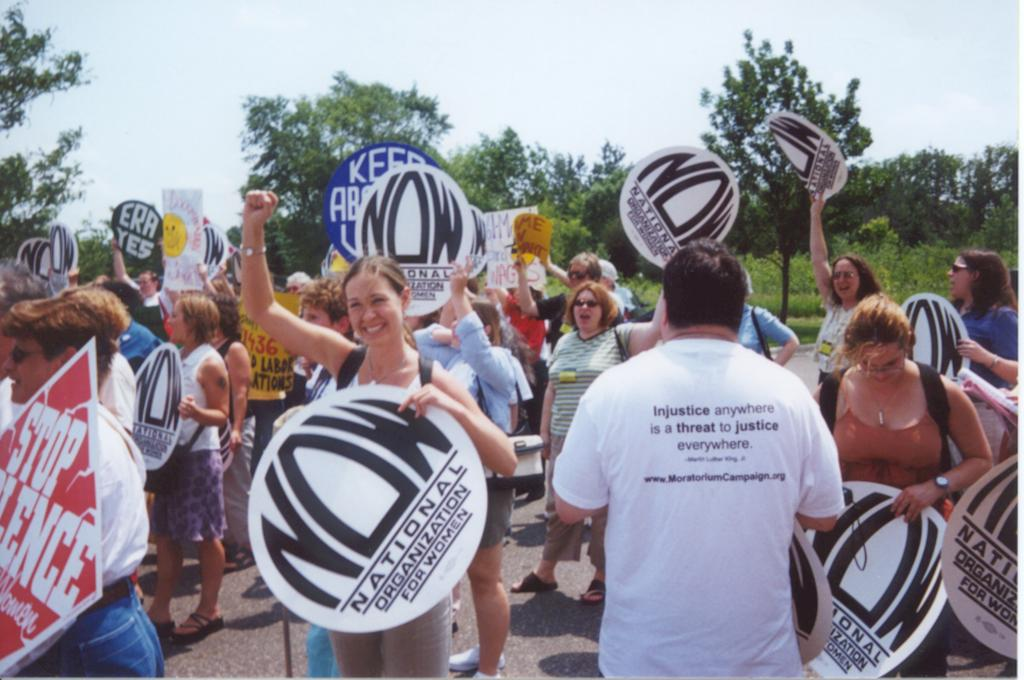How many people are in the group in the image? There is a group of people in the image, but the exact number is not specified. What are some people in the group holding? Some people in the group are holding boards. What can be seen in the background of the image? There are trees in the background of the image. What is visible at the top of the image? The sky is visible in the image. Where is the faucet located in the image? There is no faucet present in the image. What type of building can be seen in the background of the image? There is no building visible in the background of the image; only trees are present. 